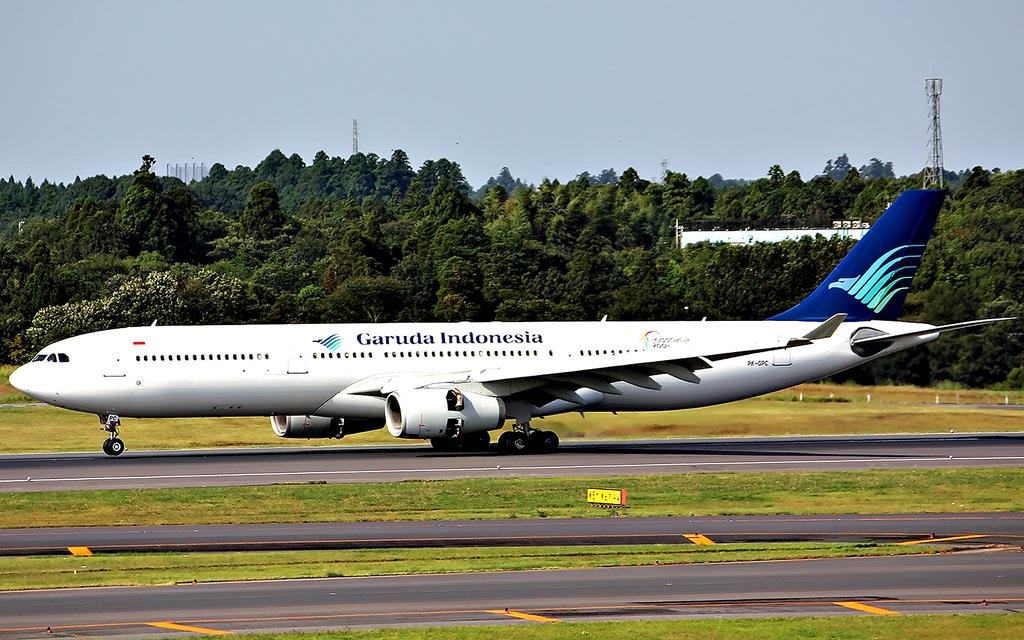What is the main subject of the image? The main subject of the image is an airplane. What colors are used to paint the airplane? The airplane is white and blue in color. Where is the airplane located in the image? The airplane is on the runway. What can be seen in the background of the image? There are trees, a tower, and a clear sky in the background of the image. Can you tell me how many scarecrows are standing near the airplane in the image? There are no scarecrows present in the image; it features an airplane on the runway with a background of trees, a tower, and a clear sky. What type of ear is visible on the airplane in the image? There are no ears visible on the airplane in the image, as it is a mode of transportation and not a living being. 